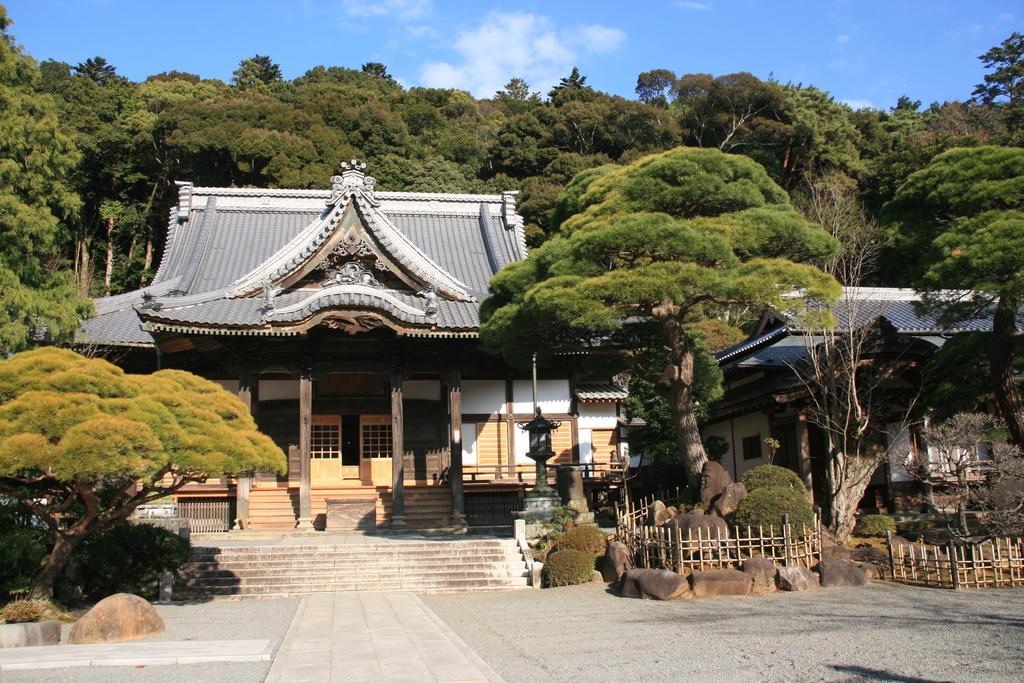Please provide a concise description of this image. In this image, we can see houses, walls, doors, pillars, stairs, railings, rocks, plants and trees. At the bottom, we can see the walkway. Top of the image, there is the sky. 